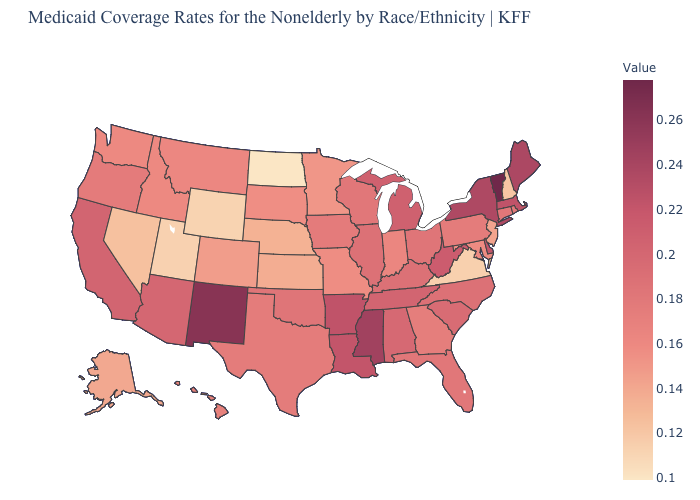Which states have the highest value in the USA?
Answer briefly. Vermont. Which states hav the highest value in the MidWest?
Be succinct. Michigan. Is the legend a continuous bar?
Answer briefly. Yes. Among the states that border Delaware , does Maryland have the highest value?
Keep it brief. No. Among the states that border Wisconsin , which have the highest value?
Keep it brief. Michigan. 